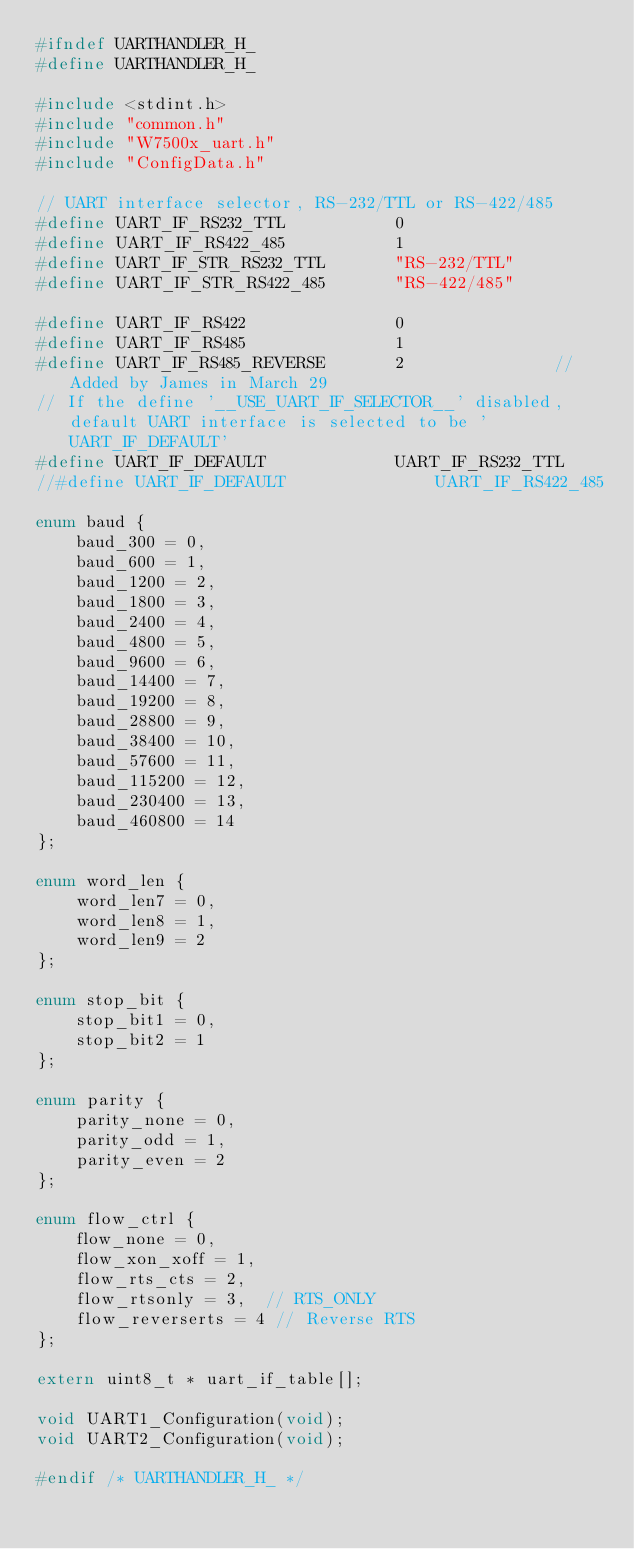Convert code to text. <code><loc_0><loc_0><loc_500><loc_500><_C_>#ifndef UARTHANDLER_H_
#define UARTHANDLER_H_

#include <stdint.h>
#include "common.h"
#include "W7500x_uart.h"
#include "ConfigData.h"

// UART interface selector, RS-232/TTL or RS-422/485
#define UART_IF_RS232_TTL			0
#define UART_IF_RS422_485			1
#define UART_IF_STR_RS232_TTL		"RS-232/TTL"
#define UART_IF_STR_RS422_485		"RS-422/485"

#define UART_IF_RS422				0
#define UART_IF_RS485				1
#define UART_IF_RS485_REVERSE		2				//Added by James in March 29
// If the define '__USE_UART_IF_SELECTOR__' disabled, default UART interface is selected to be 'UART_IF_DEFAULT'
#define UART_IF_DEFAULT				UART_IF_RS232_TTL
//#define UART_IF_DEFAULT				UART_IF_RS422_485

enum baud {
	baud_300 = 0,
	baud_600 = 1,
	baud_1200 = 2,
	baud_1800 = 3,
	baud_2400 = 4,
	baud_4800 = 5,
	baud_9600 = 6,
	baud_14400 = 7,
	baud_19200 = 8,
	baud_28800 = 9,
	baud_38400 = 10,
	baud_57600 = 11,
	baud_115200 = 12,
	baud_230400 = 13,
    baud_460800 = 14
};

enum word_len {
	word_len7 = 0,
	word_len8 = 1,
	word_len9 = 2
};

enum stop_bit {
	stop_bit1 = 0,
	stop_bit2 = 1
};

enum parity {
	parity_none = 0,
	parity_odd = 1,
	parity_even = 2
};

enum flow_ctrl {
	flow_none = 0,
	flow_xon_xoff = 1,
	flow_rts_cts = 2,
	flow_rtsonly = 3,  // RTS_ONLY
	flow_reverserts = 4 // Reverse RTS
};

extern uint8_t * uart_if_table[];

void UART1_Configuration(void);
void UART2_Configuration(void);

#endif /* UARTHANDLER_H_ */
</code> 